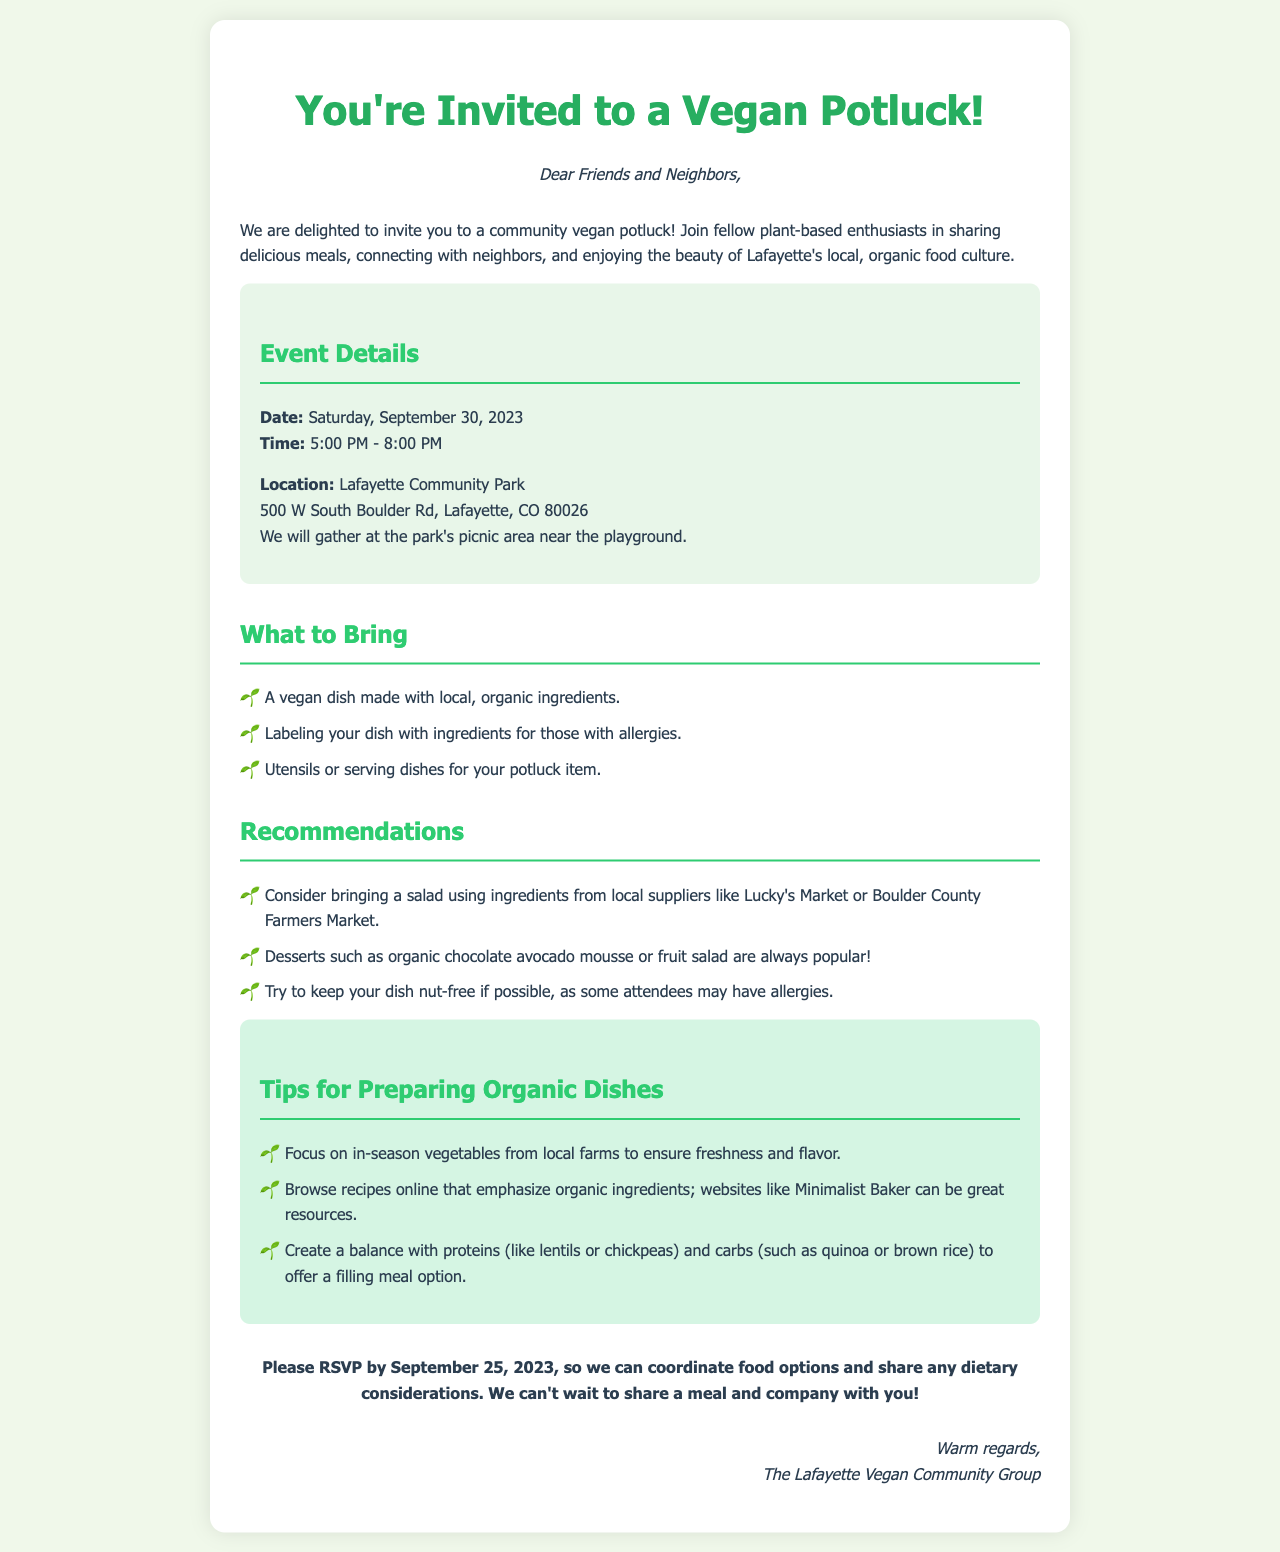What is the date of the potluck? The date of the potluck is explicitly stated in the document under "Event Details."
Answer: Saturday, September 30, 2023 What time does the event start? The start time is specified in the "Event Details" section, indicating the beginning of the potluck.
Answer: 5:00 PM Where is the potluck taking place? The document clearly states the location in the "Event Details" section.
Answer: Lafayette Community Park What should attendees label their dish with? This requirement is mentioned in the "What to Bring" section of the document.
Answer: Ingredients for allergies What type of market is suggested for local ingredients? The document provides suggestions for local suppliers where attendees can source ingredients for their dishes.
Answer: Boulder County Farmers Market What is a suggested dessert for the potluck? The recommendations section lists specific dessert ideas that attendees can consider bringing.
Answer: Organic chocolate avocado mousse What is a key focus when preparing organic dishes? This tip is mentioned within the "Tips for Preparing Organic Dishes" section and emphasizes sourcing for freshness.
Answer: In-season vegetables By when should attendees RSVP? The RSVP date is clearly highlighted in the conclusion of the invitation.
Answer: September 25, 2023 Who is hosting the potluck? The letter concludes with the name of the group organizing the event.
Answer: The Lafayette Vegan Community Group 